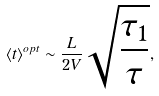<formula> <loc_0><loc_0><loc_500><loc_500>\langle t \rangle ^ { o p t } \sim \frac { L } { 2 V } \sqrt { \frac { \tau _ { 1 } } { \tau } } ,</formula> 